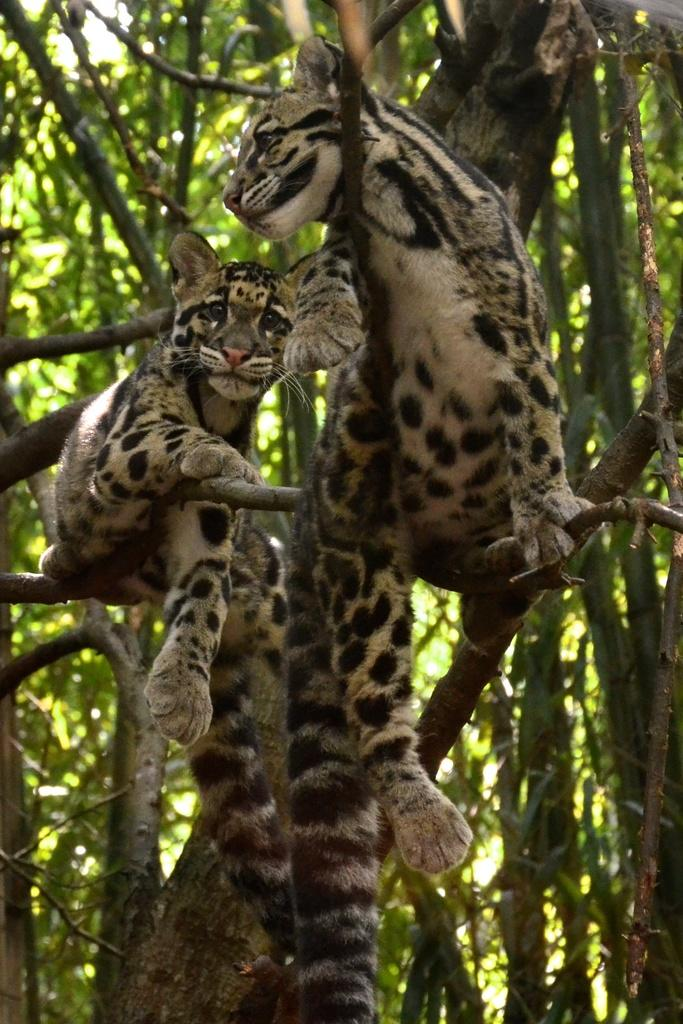What animals are present in the image? There are leopard cubs in the image. Where are the leopard cubs located? The leopard cubs are on the branches of a tree. What type of vegetation is visible in the image? There are trees visible in the image. What type of club can be seen in the image? There is no club present in the image. Is there a ring visible in the image? There is no ring present in the image. 